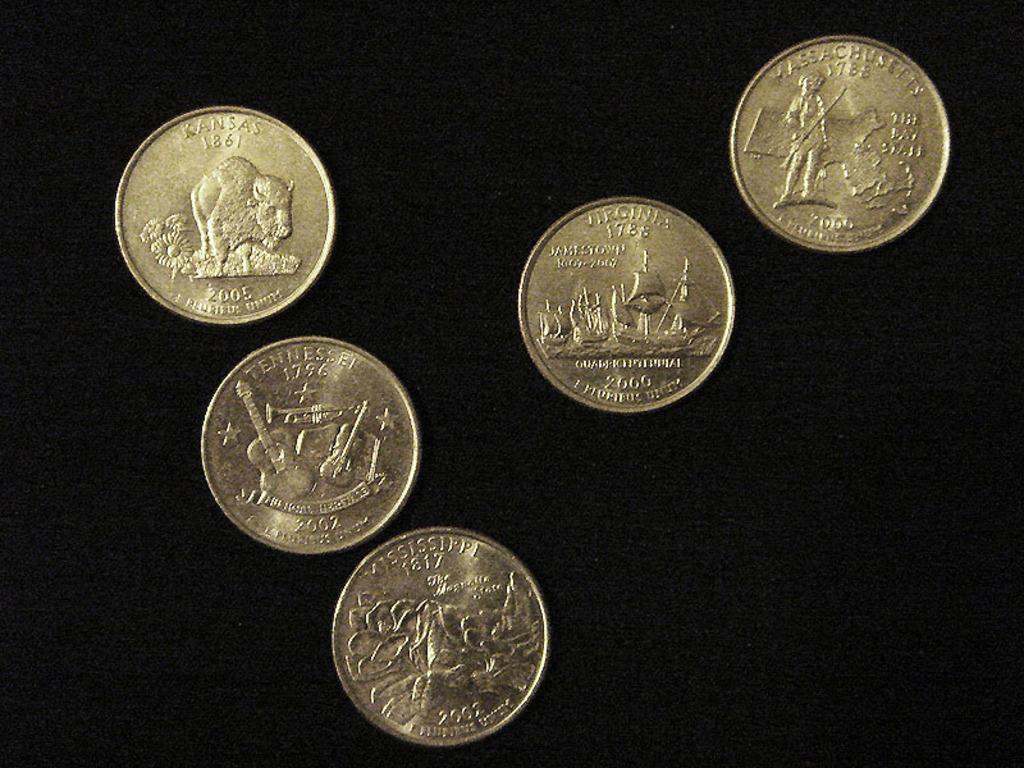What year is the kansas quarter?
Provide a short and direct response. 2005. What state is the coin with the buffalo from?
Ensure brevity in your answer.  Kansas. 